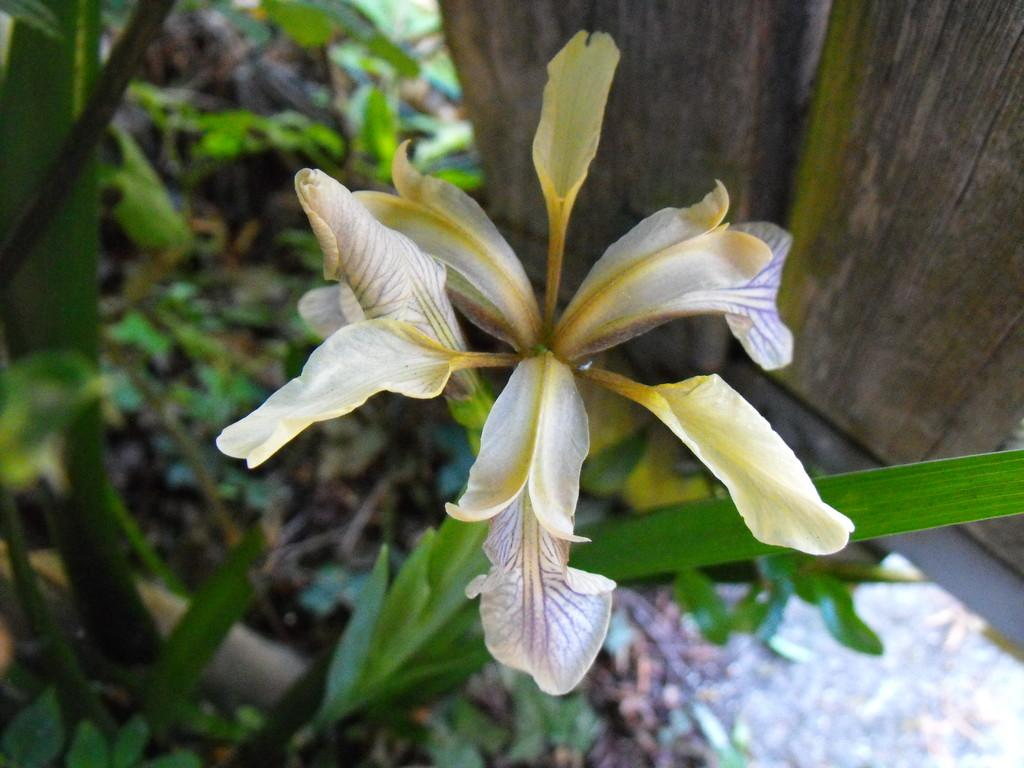Where was the picture taken? The picture was clicked outside. What is the main subject of the image? There is a flower in the center of the image. What are the flower's components? The flower has leaves. What can be seen in the background of the image? There are wooden objects and plants in the background of the image. What type of quilt is visible in the image? There is no quilt present in the image. How many feet are visible in the image? There are no feet visible in the image. 